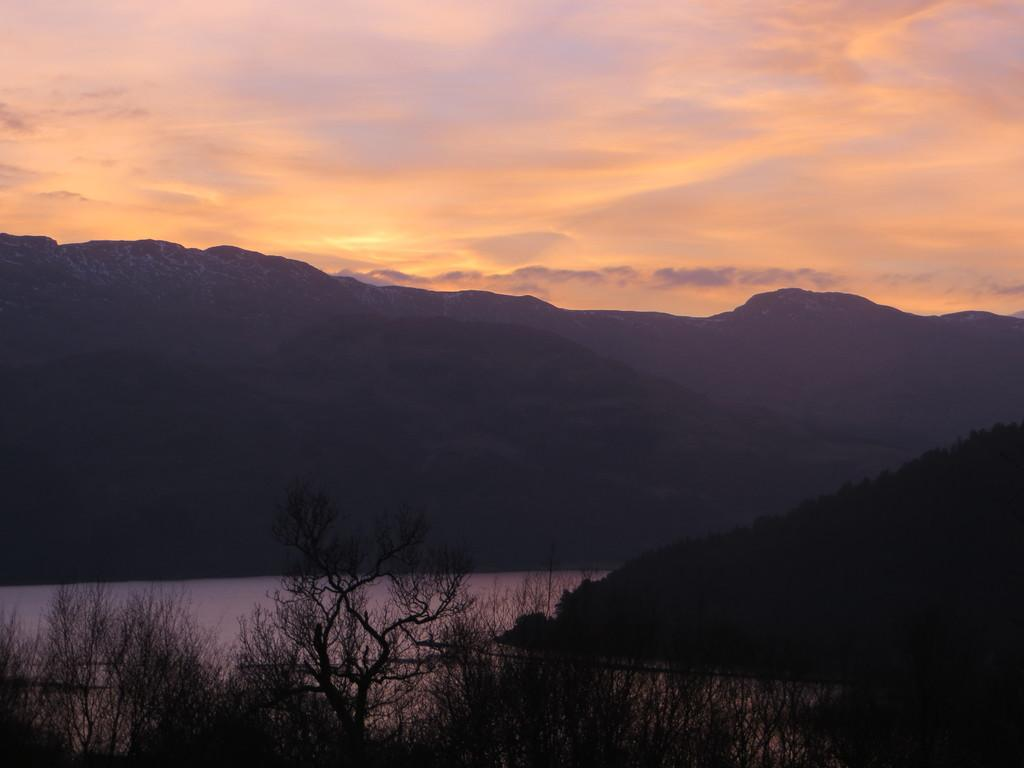What type of vegetation can be seen in the image? There are trees in the image. What natural feature is present in the image? There is a canal in the image. How is the canal positioned in relation to the hills? The canal is situated between hills. What is visible at the top of the image? The sky is visible at the top of the image. What type of berry is growing on the trees in the image? There is no mention of berries in the image; the trees are not described as having berries. What sense is being stimulated by the image? The image is visual, so it primarily stimulates the sense of sight. 